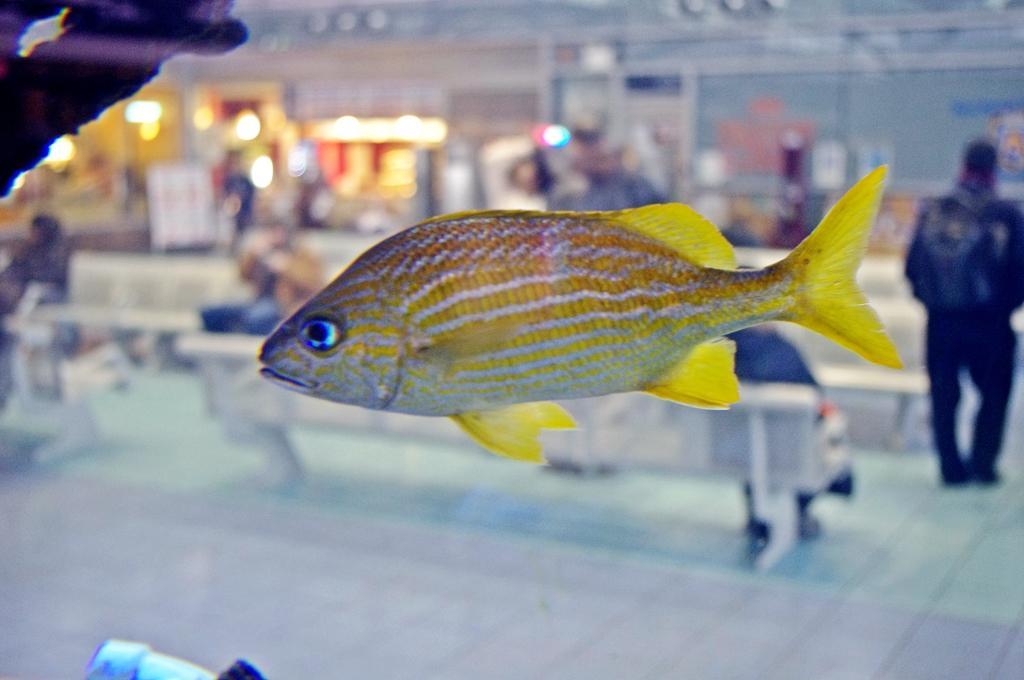Please provide a concise description of this image. In this picture we can see a yellow fish and behind the fish there are groups of people sitting and some people are standing. Behind the people there is a blurred background. 